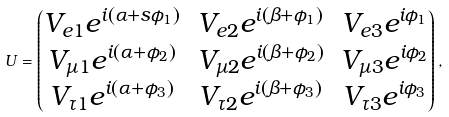Convert formula to latex. <formula><loc_0><loc_0><loc_500><loc_500>U = \begin{pmatrix} V _ { e 1 } e ^ { i ( \alpha + s \phi _ { 1 } ) } & V _ { e 2 } e ^ { i ( \beta + \phi _ { 1 } ) } & V _ { e 3 } e ^ { i \phi _ { 1 } } \\ V _ { \mu 1 } e ^ { i ( \alpha + \phi _ { 2 } ) } & V _ { \mu 2 } e ^ { i ( \beta + \phi _ { 2 } ) } & V _ { \mu 3 } e ^ { i \phi _ { 2 } } \\ V _ { \tau 1 } e ^ { i ( \alpha + \phi _ { 3 } ) } & V _ { \tau 2 } e ^ { i ( \beta + \phi _ { 3 } ) } & V _ { \tau 3 } e ^ { i \phi _ { 3 } } \\ \end{pmatrix} ,</formula> 